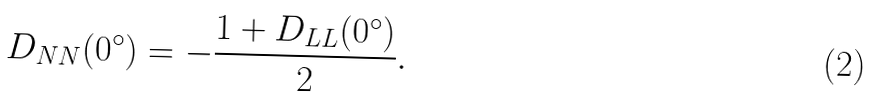Convert formula to latex. <formula><loc_0><loc_0><loc_500><loc_500>D _ { N N } ( 0 ^ { \circ } ) = - \frac { 1 + D _ { L L } ( 0 ^ { \circ } ) } { 2 } .</formula> 